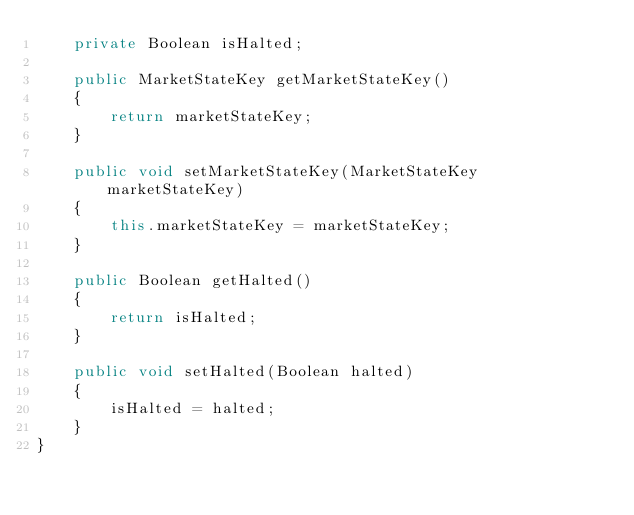<code> <loc_0><loc_0><loc_500><loc_500><_Java_>    private Boolean isHalted;

    public MarketStateKey getMarketStateKey()
    {
        return marketStateKey;
    }

    public void setMarketStateKey(MarketStateKey marketStateKey)
    {
        this.marketStateKey = marketStateKey;
    }

    public Boolean getHalted()
    {
        return isHalted;
    }

    public void setHalted(Boolean halted)
    {
        isHalted = halted;
    }
}
</code> 